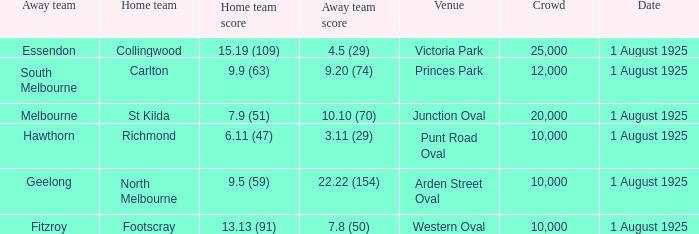What was the away team's score at the match played at The Western Oval? 7.8 (50). 